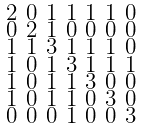Convert formula to latex. <formula><loc_0><loc_0><loc_500><loc_500>\begin{smallmatrix} 2 & 0 & 1 & 1 & 1 & 1 & 0 \\ 0 & 2 & 1 & 0 & 0 & 0 & 0 \\ 1 & 1 & 3 & 1 & 1 & 1 & 0 \\ 1 & 0 & 1 & 3 & 1 & 1 & 1 \\ 1 & 0 & 1 & 1 & 3 & 0 & 0 \\ 1 & 0 & 1 & 1 & 0 & 3 & 0 \\ 0 & 0 & 0 & 1 & 0 & 0 & 3 \end{smallmatrix}</formula> 